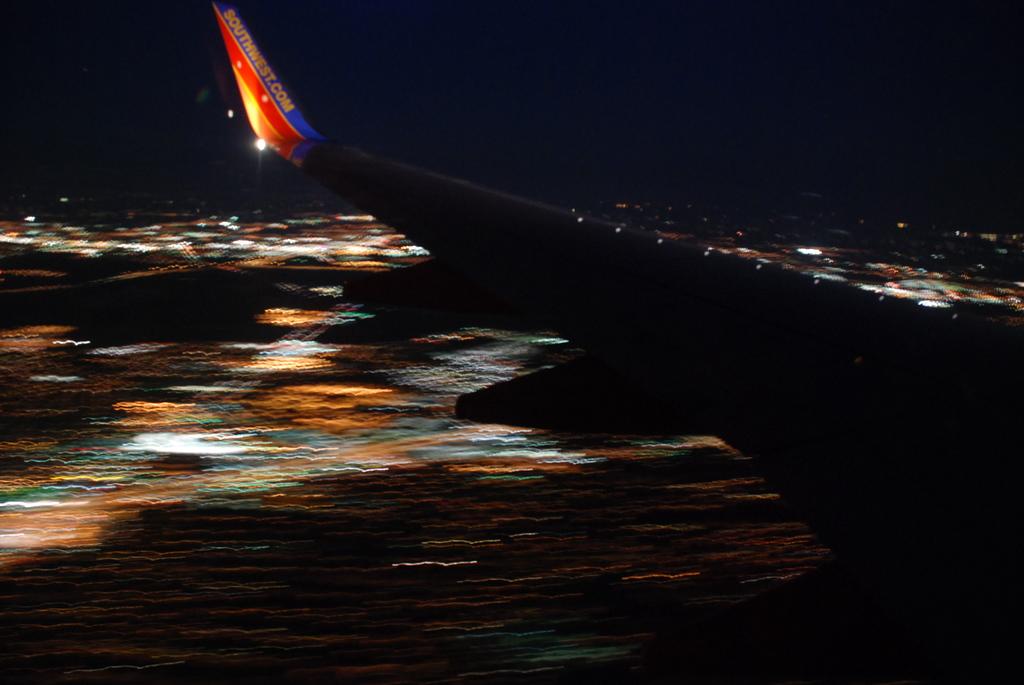What is the airline this plane is flying for?
Provide a short and direct response. Southwest. 